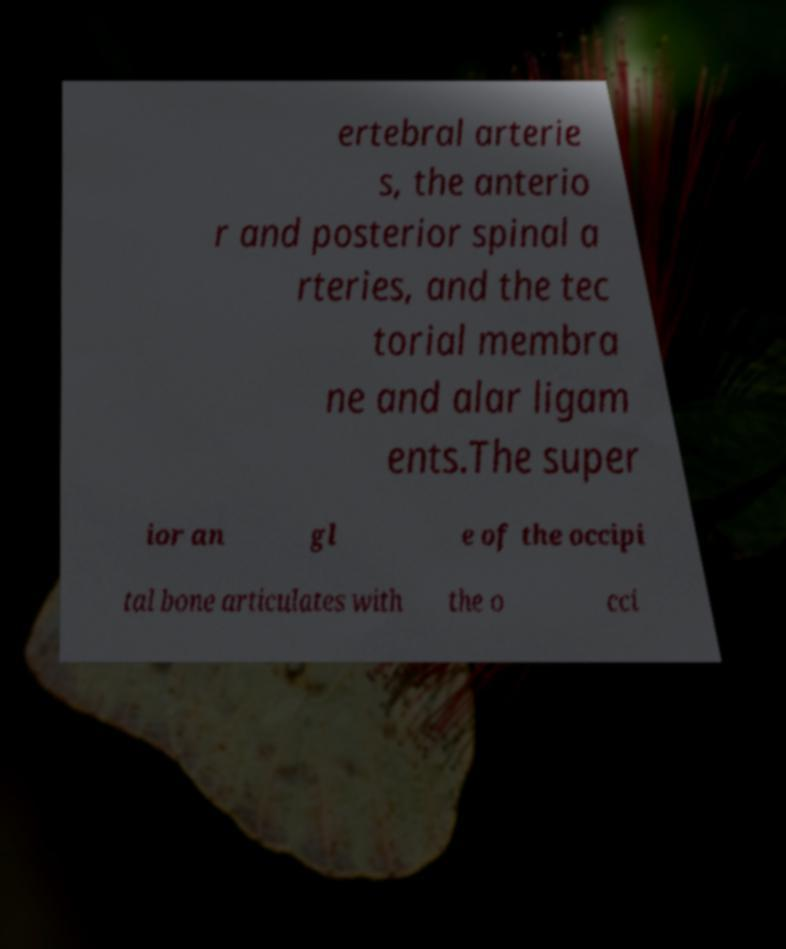There's text embedded in this image that I need extracted. Can you transcribe it verbatim? ertebral arterie s, the anterio r and posterior spinal a rteries, and the tec torial membra ne and alar ligam ents.The super ior an gl e of the occipi tal bone articulates with the o cci 